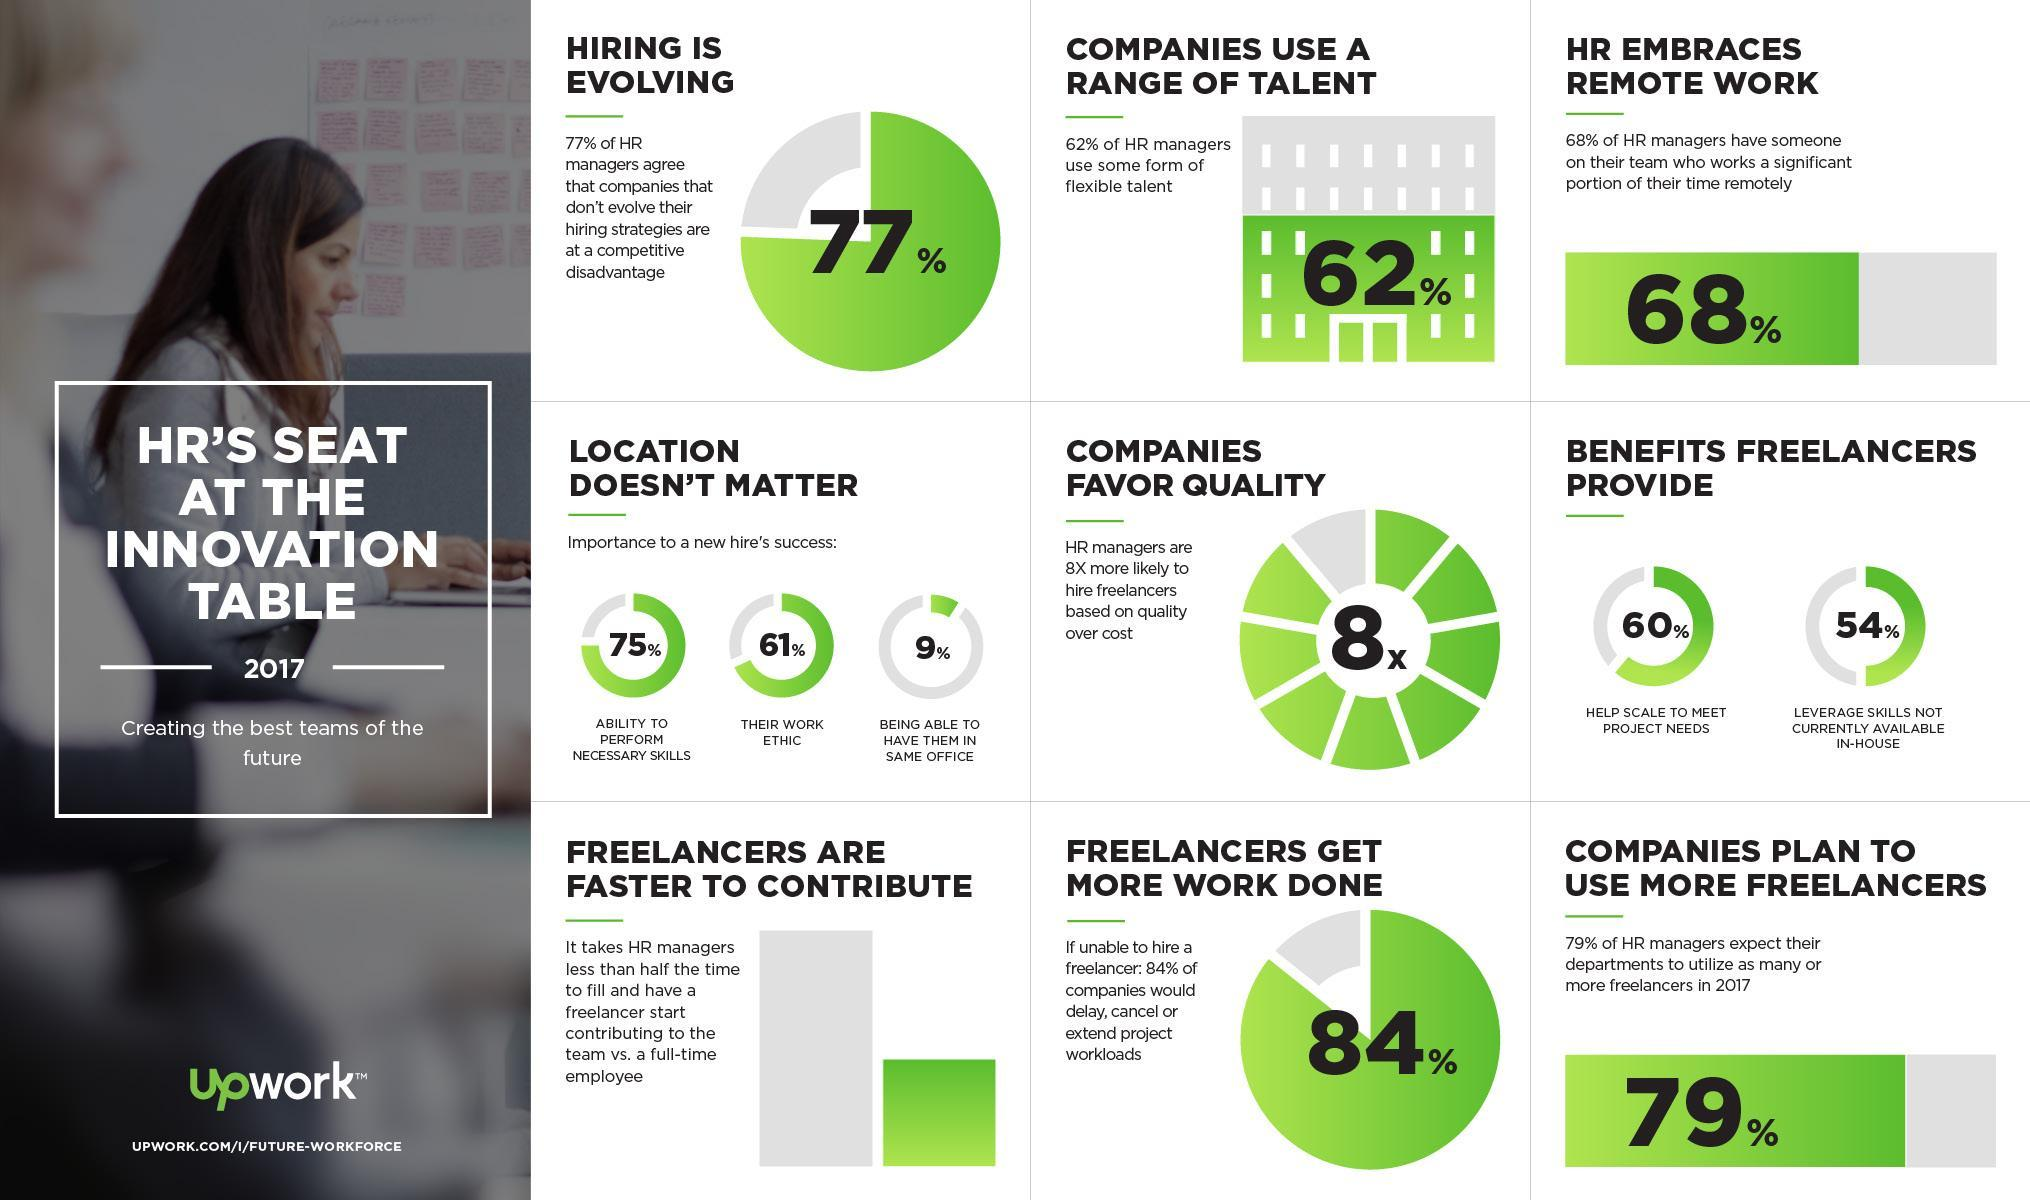What percentage of companies has no plan to use more freelancers in 2017?
Answer the question with a short phrase. 21% What percentage of companies do not cancel or extend their project if unable to hire a freelancer? 16% 